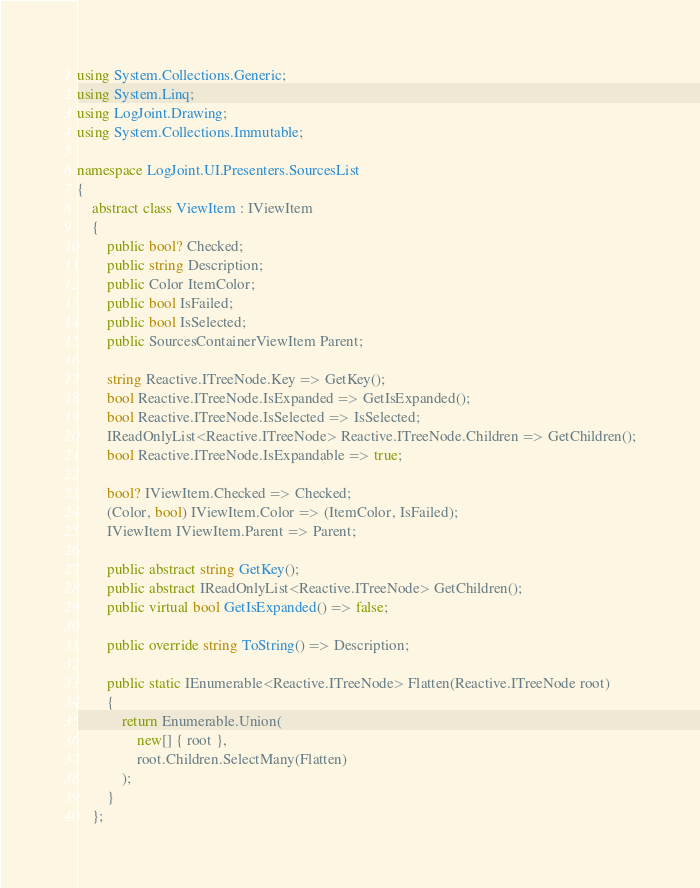<code> <loc_0><loc_0><loc_500><loc_500><_C#_>using System.Collections.Generic;
using System.Linq;
using LogJoint.Drawing;
using System.Collections.Immutable;

namespace LogJoint.UI.Presenters.SourcesList
{
	abstract class ViewItem : IViewItem
	{
		public bool? Checked;
		public string Description;
		public Color ItemColor;
		public bool IsFailed;
		public bool IsSelected;
		public SourcesContainerViewItem Parent;

		string Reactive.ITreeNode.Key => GetKey();
		bool Reactive.ITreeNode.IsExpanded => GetIsExpanded();
		bool Reactive.ITreeNode.IsSelected => IsSelected;
		IReadOnlyList<Reactive.ITreeNode> Reactive.ITreeNode.Children => GetChildren();
		bool Reactive.ITreeNode.IsExpandable => true;

		bool? IViewItem.Checked => Checked;
		(Color, bool) IViewItem.Color => (ItemColor, IsFailed);
		IViewItem IViewItem.Parent => Parent;

		public abstract string GetKey();
		public abstract IReadOnlyList<Reactive.ITreeNode> GetChildren();
		public virtual bool GetIsExpanded() => false;

		public override string ToString() => Description;

		public static IEnumerable<Reactive.ITreeNode> Flatten(Reactive.ITreeNode root)
		{
			return Enumerable.Union(
				new[] { root },
				root.Children.SelectMany(Flatten)
			);
		}
	};
</code> 